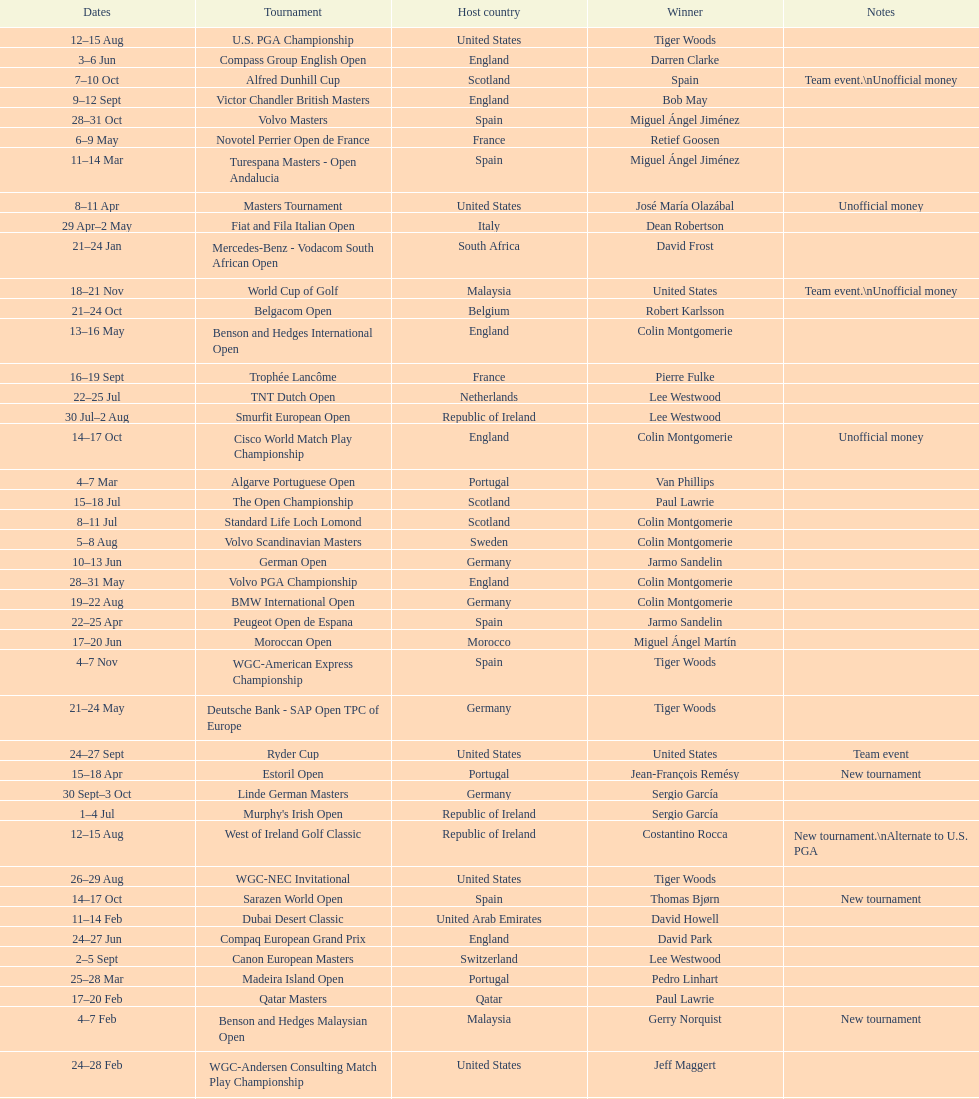How many consecutive times was south africa the host country? 2. 